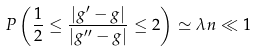Convert formula to latex. <formula><loc_0><loc_0><loc_500><loc_500>P \left ( \frac { 1 } { 2 } \leq \frac { | { g } ^ { \prime } - { g } | } { | { g } ^ { \prime \prime } - { g } | } \leq 2 \right ) \simeq \lambda n \ll 1</formula> 